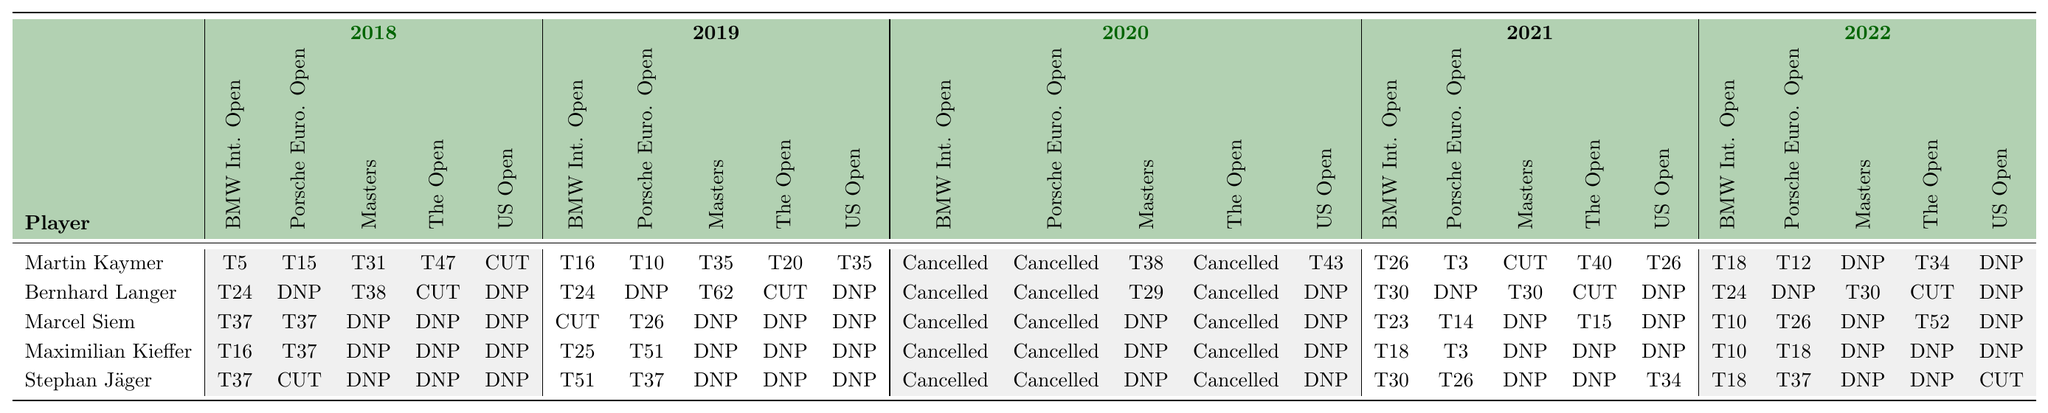What was Martin Kaymer's best finish in the 2018 BMW International Open? In the table, Martin Kaymer's finish in the 2018 BMW International Open is listed as T5, which indicates he tied for 5th place.
Answer: T5 How many tournaments did Bernhard Langer participate in during 2020? The table shows that all tournaments listed for Bernhard Langer in 2020 are marked as Cancelled, so he did not participate in any tournaments that year.
Answer: 0 Which player had the highest finish in the 2021 Porsche European Open? By examining the 2021 Porsche European Open results, Maximilian Kieffer finished in T3, while Martin Kaymer and Stephan Jäger also finished in T3, but Langer and Siem had worse finishes; thus, T3 is the highest position.
Answer: T3 Did Marcel Siem make the cut in the 2019 Masters Tournament? Looking at the table, Marcel Siem is noted as DNP in the 2019 Masters Tournament, indicating he did not participate, so he did not make the cut.
Answer: No How many cuts did Stephan Jäger make in 2021 across the tournaments listed? For 2021, Jäger's finishes are shown as T30 (BMW International Open), T26 (Porsche European Open), CUT (Masters Tournament), DNP (The Open Championship), and T34 (US Open). He made the cut in 2021 in two tournaments: BMW International Open and Porsche European Open.
Answer: 2 What is the total number of tournaments played by Maximilian Kieffer from 2018 to 2022? Counting the entries for Kieffer, he has results in 9 tournaments over the specified years, omitting the Cancelled and DNP as no participation means no counts.
Answer: 9 In which year did Martin Kaymer have the most tournament cancellations? In the table, 2020 has entries marked as Cancelled for all tournaments listed for Martin Kaymer, which is the only year with full cancellations.
Answer: 2020 What was the average finish position of Bernhard Langer across all tournaments in 2019 where he played? To calculate the average, we consider only the positions: T24, T62 (the other tournaments are either DNP or CUT). The average is calculated as (24 + 62) / 2 = 43.
Answer: 43 Did any player achieve a top 10 finish in the 2022 US Open? In the table, Martin Kaymer's result in the 2022 US Open shows DNP, while the results of other German players also indicate no finishes in the top 10.
Answer: No Which player had the best overall performance in the 2021 BMW International Open? In 2021, Martin Kaymer finished T26, Bernhard Langer T30, Marcel Siem T23, Maximilian Kieffer T18, and Stephan Jäger also T30. The best among these is Kieffer at T18.
Answer: Maximilian Kieffer 